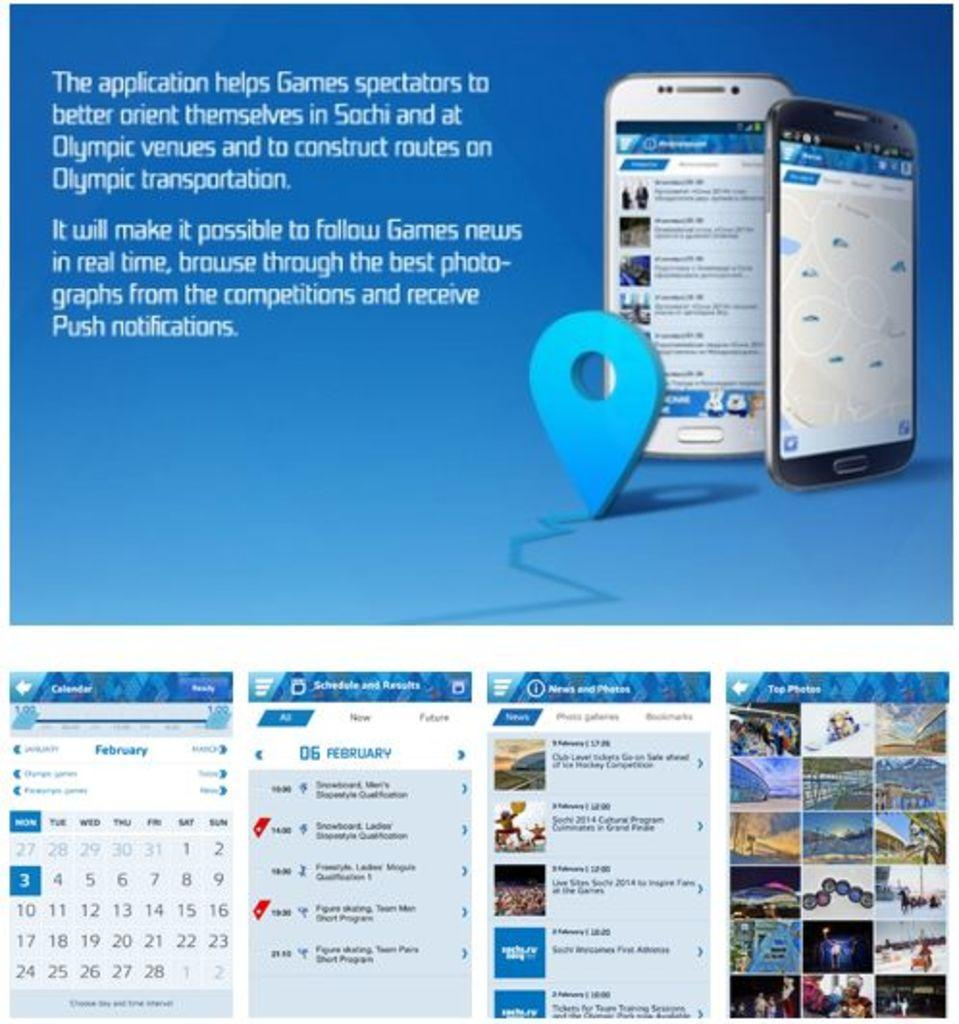<image>
Write a terse but informative summary of the picture. the description an app meant to help spectators of the Sochi olympics 